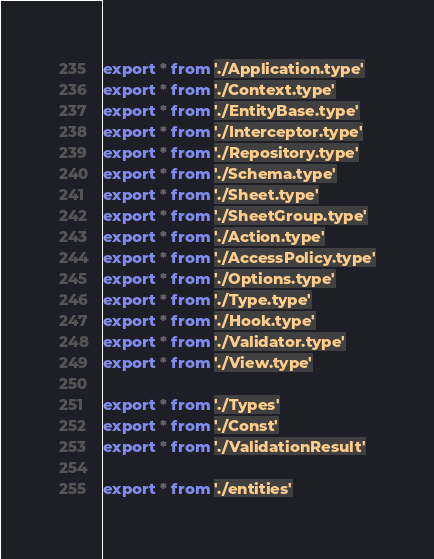<code> <loc_0><loc_0><loc_500><loc_500><_TypeScript_>export * from './Application.type'
export * from './Context.type'
export * from './EntityBase.type'
export * from './Interceptor.type'
export * from './Repository.type'
export * from './Schema.type'
export * from './Sheet.type'
export * from './SheetGroup.type'
export * from './Action.type'
export * from './AccessPolicy.type'
export * from './Options.type'
export * from './Type.type'
export * from './Hook.type'
export * from './Validator.type'
export * from './View.type'

export * from './Types'
export * from './Const'
export * from './ValidationResult'

export * from './entities'
</code> 